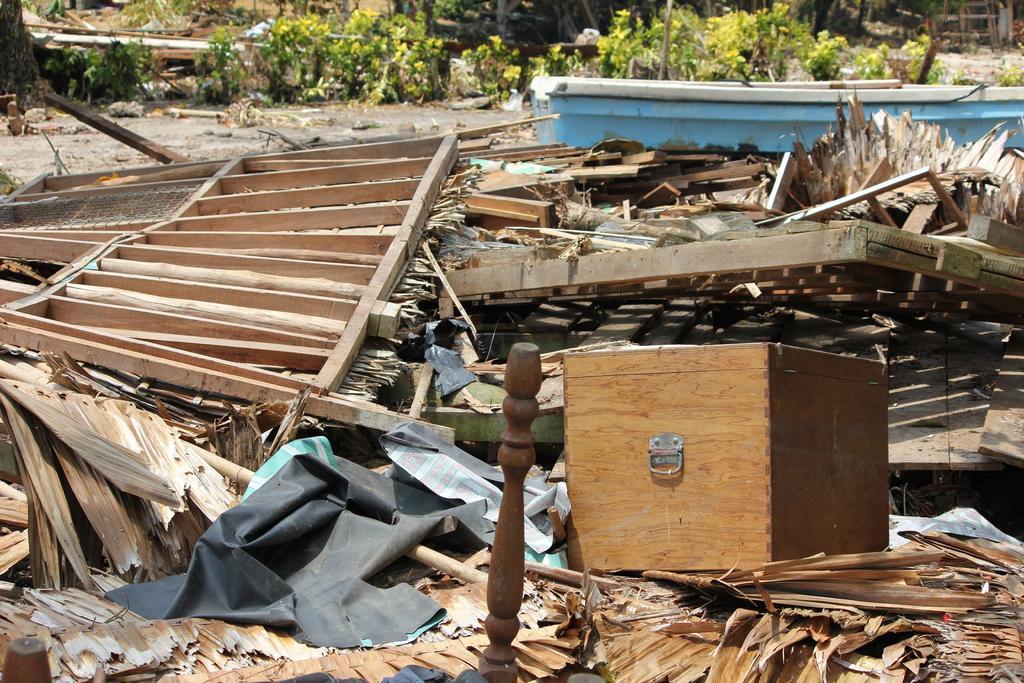Please provide a concise description of this image. In this image, we can see a wooden box, some logs, wooden stands and there are plants, poles and we can see dry leaves and some objects. 